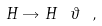<formula> <loc_0><loc_0><loc_500><loc_500>H \rightarrow H \ \vartheta \ ,</formula> 